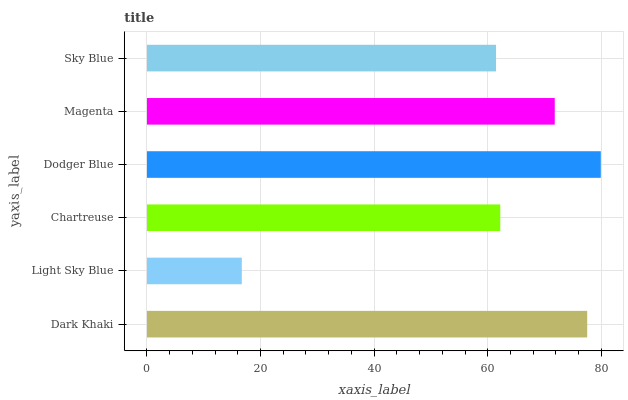Is Light Sky Blue the minimum?
Answer yes or no. Yes. Is Dodger Blue the maximum?
Answer yes or no. Yes. Is Chartreuse the minimum?
Answer yes or no. No. Is Chartreuse the maximum?
Answer yes or no. No. Is Chartreuse greater than Light Sky Blue?
Answer yes or no. Yes. Is Light Sky Blue less than Chartreuse?
Answer yes or no. Yes. Is Light Sky Blue greater than Chartreuse?
Answer yes or no. No. Is Chartreuse less than Light Sky Blue?
Answer yes or no. No. Is Magenta the high median?
Answer yes or no. Yes. Is Chartreuse the low median?
Answer yes or no. Yes. Is Light Sky Blue the high median?
Answer yes or no. No. Is Dodger Blue the low median?
Answer yes or no. No. 